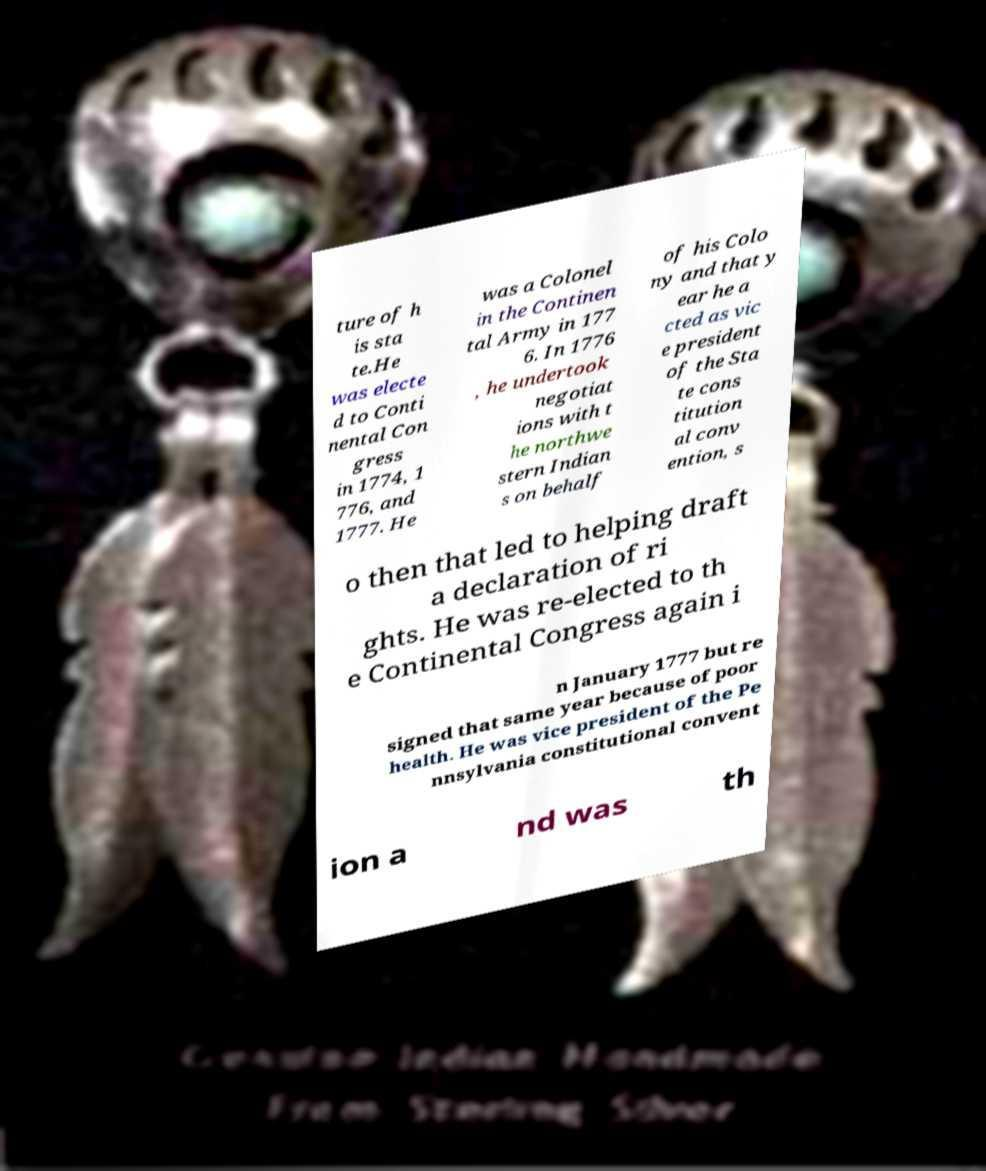What messages or text are displayed in this image? I need them in a readable, typed format. ture of h is sta te.He was electe d to Conti nental Con gress in 1774, 1 776, and 1777. He was a Colonel in the Continen tal Army in 177 6. In 1776 , he undertook negotiat ions with t he northwe stern Indian s on behalf of his Colo ny and that y ear he a cted as vic e president of the Sta te cons titution al conv ention, s o then that led to helping draft a declaration of ri ghts. He was re-elected to th e Continental Congress again i n January 1777 but re signed that same year because of poor health. He was vice president of the Pe nnsylvania constitutional convent ion a nd was th 